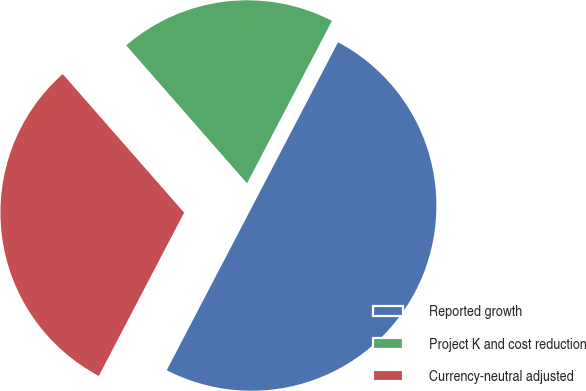<chart> <loc_0><loc_0><loc_500><loc_500><pie_chart><fcel>Reported growth<fcel>Project K and cost reduction<fcel>Currency-neutral adjusted<nl><fcel>50.0%<fcel>19.11%<fcel>30.89%<nl></chart> 